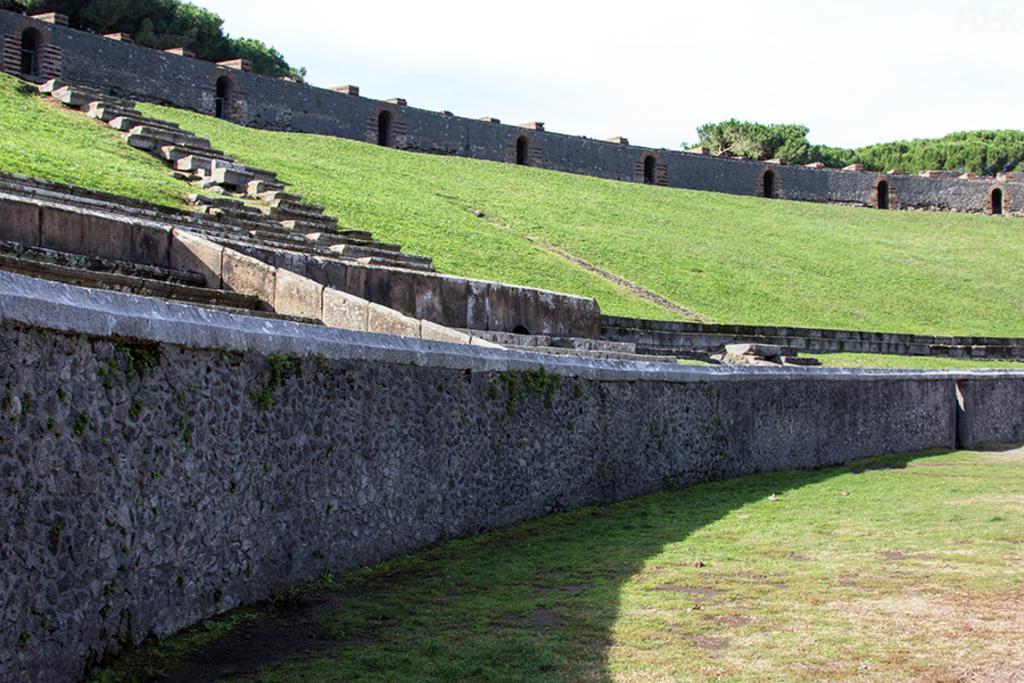Please provide a concise description of this image. In this picture I can see the stairs, wall and other structures. In the center I can see the grass. In the background I can see many trees. At the top I can see the sky and clouds. 